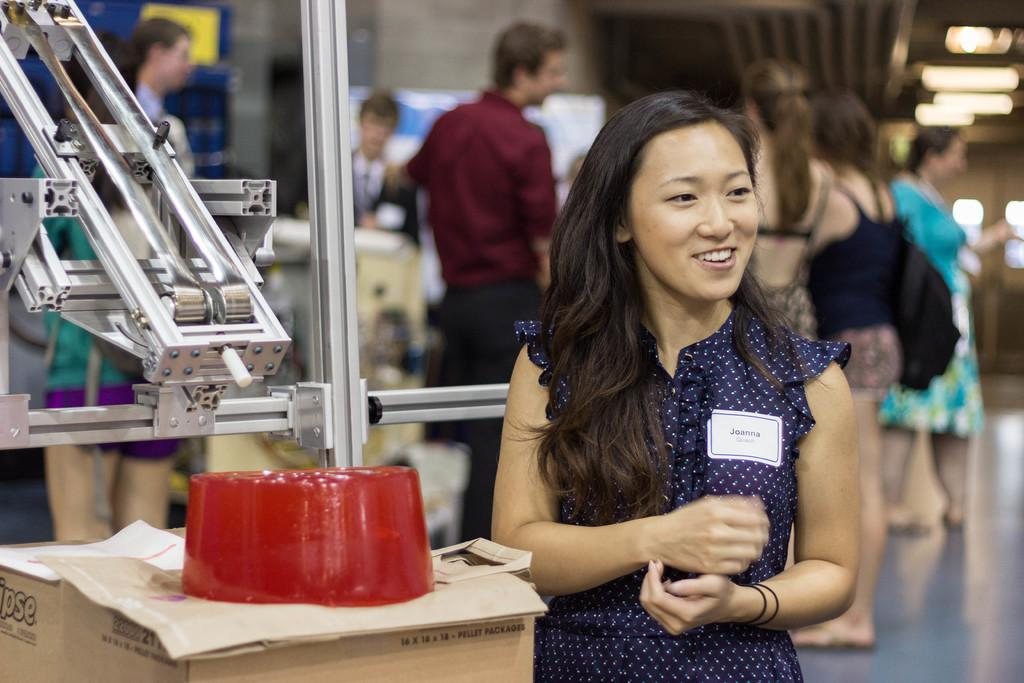Who is present in the image? There is a lady in the image. What is the lady doing in the image? The lady is standing beside a machine. Can you describe the red color object in the image? There is a red color object on a cardboard box. Are there any other people visible in the image? Yes, there are people standing at the back in the image. What type of pickle is the lady holding in the image? There is no pickle present in the image. Can you tell me the name of the lady's daughter in the image? There is no mention of a daughter in the image. 